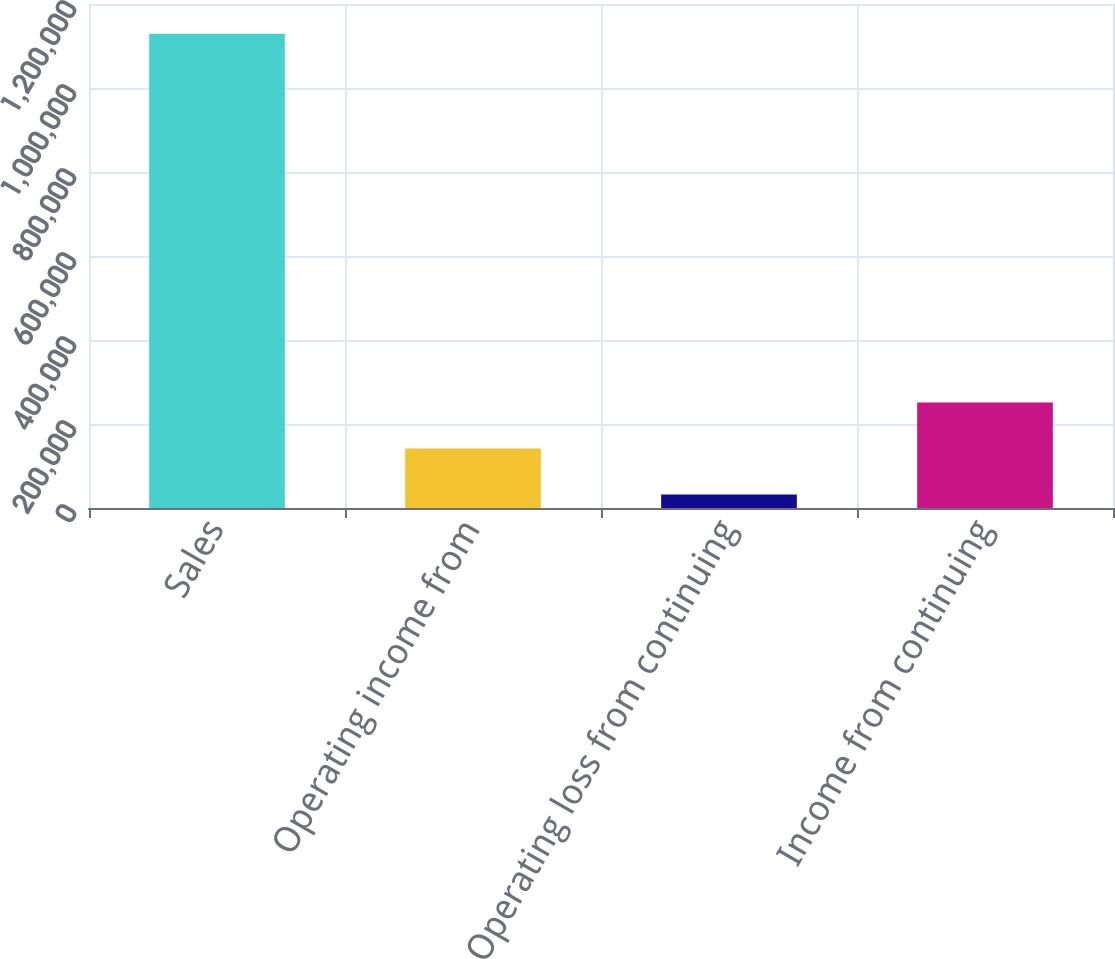Convert chart. <chart><loc_0><loc_0><loc_500><loc_500><bar_chart><fcel>Sales<fcel>Operating income from<fcel>Operating loss from continuing<fcel>Income from continuing<nl><fcel>1.12918e+06<fcel>141710<fcel>31991<fcel>251429<nl></chart> 